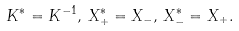Convert formula to latex. <formula><loc_0><loc_0><loc_500><loc_500>K ^ { * } = K ^ { - 1 } , \, X _ { + } ^ { * } = X _ { - } , \, X _ { - } ^ { * } = X _ { + } .</formula> 